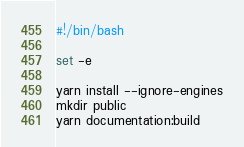Convert code to text. <code><loc_0><loc_0><loc_500><loc_500><_Bash_>#!/bin/bash

set -e

yarn install --ignore-engines
mkdir public
yarn documentation:build
</code> 